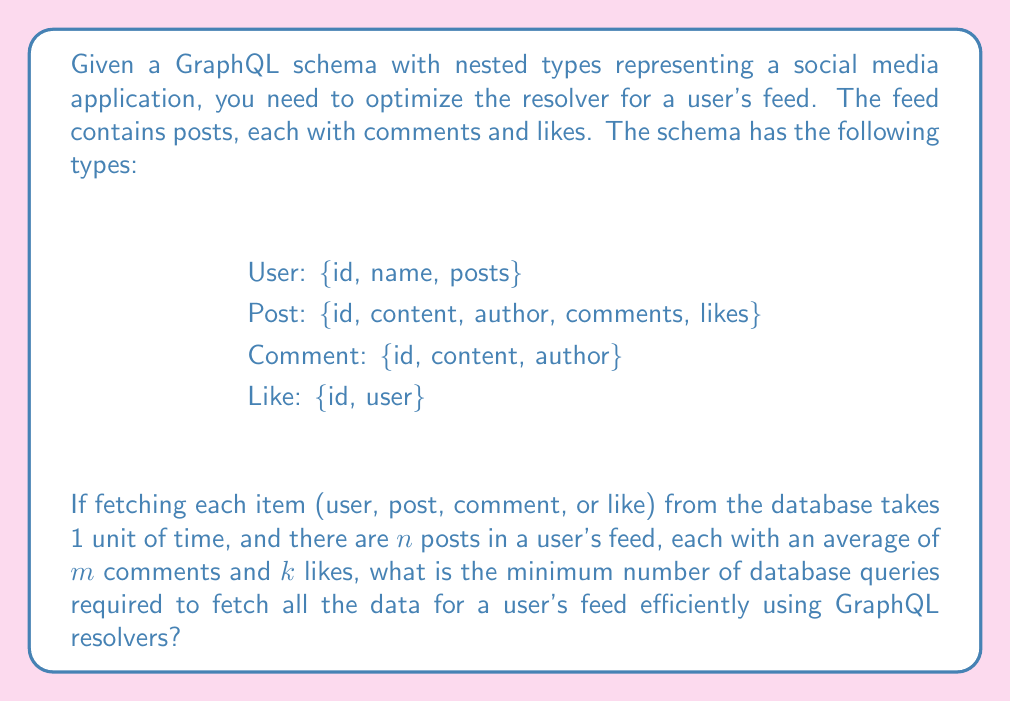Can you answer this question? To solve this problem, we need to consider the structure of the data and how GraphQL resolvers work. Let's break it down step by step:

1. First, we need to fetch the user's data, which takes 1 query.

2. Next, we fetch all the posts for the user's feed. Instead of fetching each post individually, we can use a single query to fetch all $n$ posts at once. This takes 1 query.

3. For comments, we have two options:
   a. Fetch comments for each post individually: $n$ queries
   b. Fetch all comments for all posts in a single query: 1 query
   Option b is more efficient, so we'll use that.

4. Similarly for likes, we can fetch all likes for all posts in a single query: 1 query

5. We also need to fetch the author data for each comment. Since we don't know if the authors are unique, we need to fetch this data separately. However, we can do this in a single query by collecting all unique author IDs from the comments and fetching their data at once: 1 query

6. The same applies to the users who liked the posts. We can fetch all unique user data for likes in a single query: 1 query

Adding up all the queries:
$$\text{Total queries} = 1 + 1 + 1 + 1 + 1 + 1 = 6$$

This approach is known as the "N+1 query problem" in GraphQL, where we avoid making separate queries for each nested item by batching our requests.

The time complexity of this approach is $O(1)$ with respect to the number of posts, comments, and likes, as we're using a fixed number of queries regardless of the amount of data.

In terms of space complexity, we're dealing with $O(n + nm + nk)$ data, but this doesn't affect the number of queries.
Answer: The minimum number of database queries required to efficiently fetch all the data for a user's feed using GraphQL resolvers is 6. 